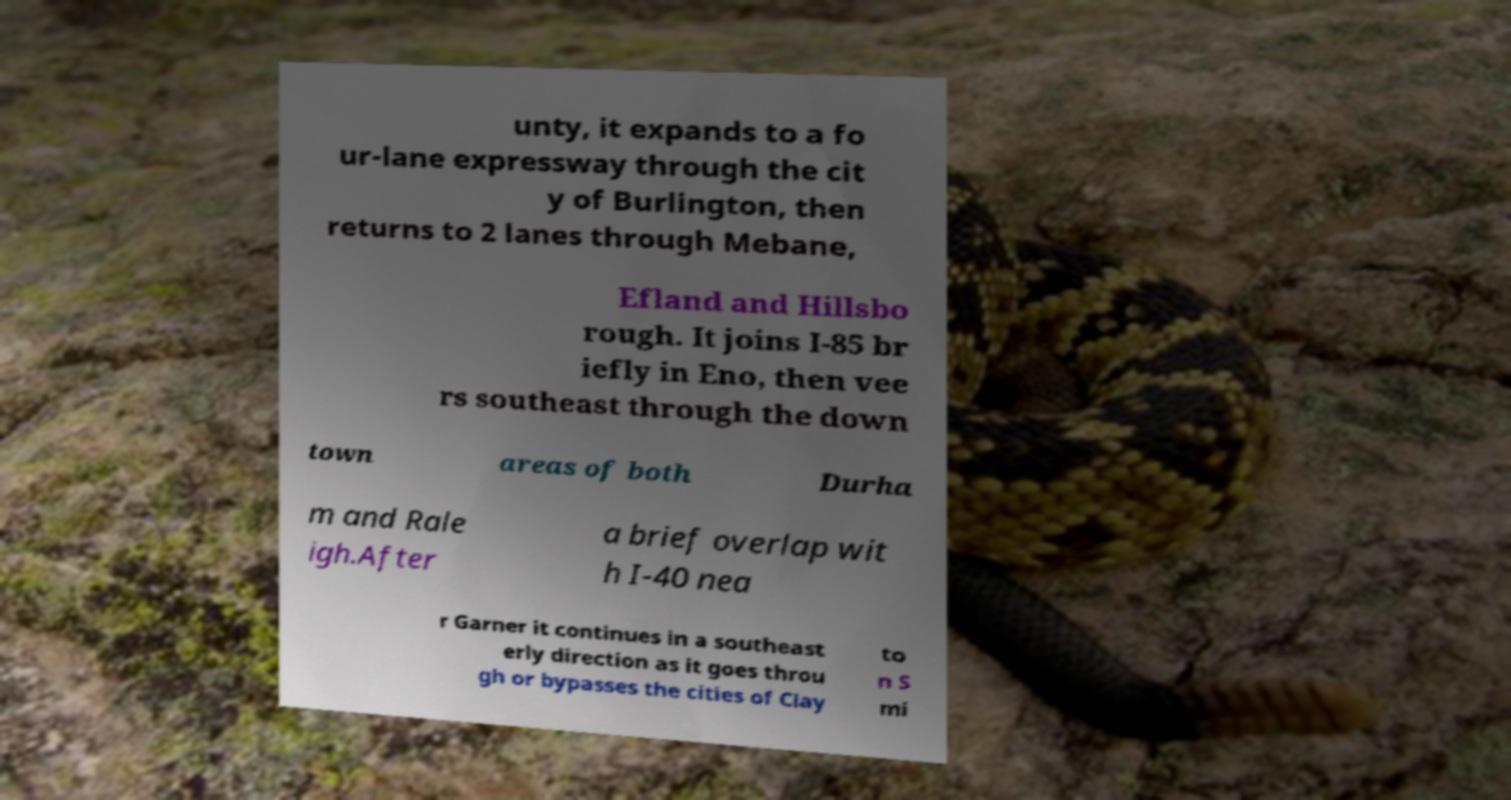What messages or text are displayed in this image? I need them in a readable, typed format. unty, it expands to a fo ur-lane expressway through the cit y of Burlington, then returns to 2 lanes through Mebane, Efland and Hillsbo rough. It joins I-85 br iefly in Eno, then vee rs southeast through the down town areas of both Durha m and Rale igh.After a brief overlap wit h I-40 nea r Garner it continues in a southeast erly direction as it goes throu gh or bypasses the cities of Clay to n S mi 